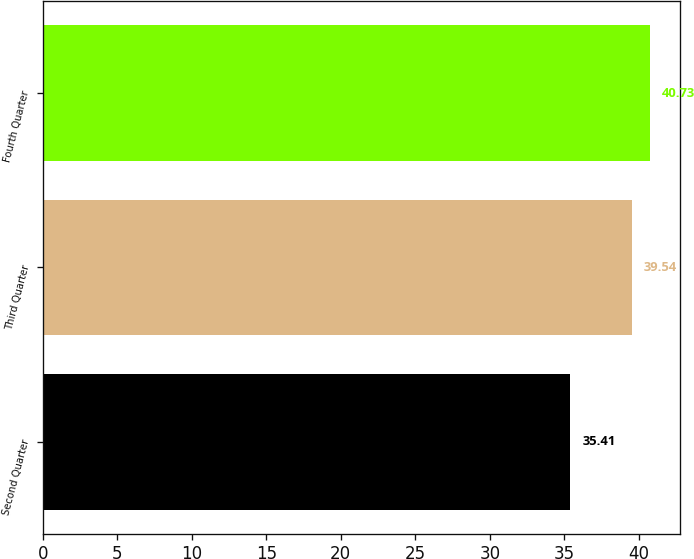Convert chart. <chart><loc_0><loc_0><loc_500><loc_500><bar_chart><fcel>Second Quarter<fcel>Third Quarter<fcel>Fourth Quarter<nl><fcel>35.41<fcel>39.54<fcel>40.73<nl></chart> 